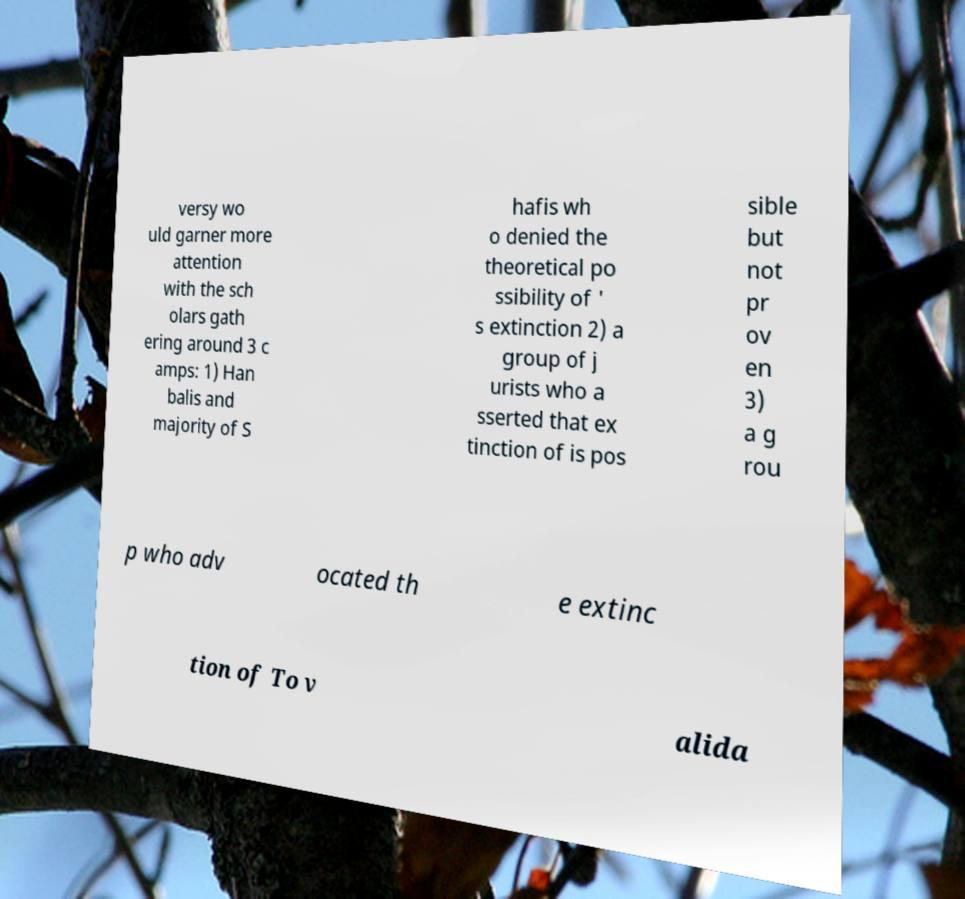There's text embedded in this image that I need extracted. Can you transcribe it verbatim? versy wo uld garner more attention with the sch olars gath ering around 3 c amps: 1) Han balis and majority of S hafis wh o denied the theoretical po ssibility of ' s extinction 2) a group of j urists who a sserted that ex tinction of is pos sible but not pr ov en 3) a g rou p who adv ocated th e extinc tion of To v alida 